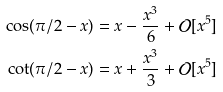<formula> <loc_0><loc_0><loc_500><loc_500>\cos ( \pi / 2 - x ) & = x - \frac { x ^ { 3 } } { 6 } + \mathcal { O } [ x ^ { 5 } ] \\ \cot ( \pi / 2 - x ) & = x + \frac { x ^ { 3 } } { 3 } + \mathcal { O } [ x ^ { 5 } ]</formula> 